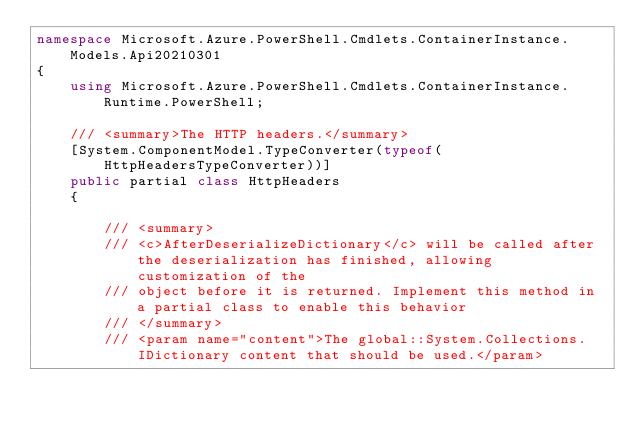Convert code to text. <code><loc_0><loc_0><loc_500><loc_500><_C#_>namespace Microsoft.Azure.PowerShell.Cmdlets.ContainerInstance.Models.Api20210301
{
    using Microsoft.Azure.PowerShell.Cmdlets.ContainerInstance.Runtime.PowerShell;

    /// <summary>The HTTP headers.</summary>
    [System.ComponentModel.TypeConverter(typeof(HttpHeadersTypeConverter))]
    public partial class HttpHeaders
    {

        /// <summary>
        /// <c>AfterDeserializeDictionary</c> will be called after the deserialization has finished, allowing customization of the
        /// object before it is returned. Implement this method in a partial class to enable this behavior
        /// </summary>
        /// <param name="content">The global::System.Collections.IDictionary content that should be used.</param>
</code> 